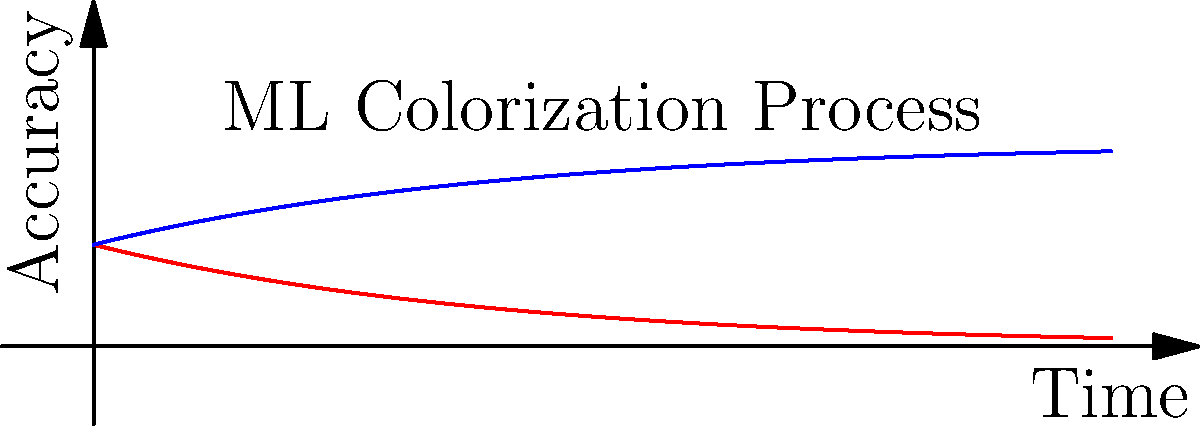In the context of using machine learning to colorize black and white film footage, what does the graph represent, and how might this information be used to improve the colorization process for classic films? The graph represents the accuracy of machine learning colorization over time. Let's break it down step-by-step:

1. The x-axis represents time, which could be interpreted as the progression of the colorization process or the evolution of the ML model.

2. The y-axis represents accuracy, indicating how close the colorized output is to the desired result.

3. The red curve (labeled "Original B&W") shows a decreasing function, which could represent the diminishing relevance or quality of the original black and white footage over time.

4. The blue curve (labeled "Colorized") shows an increasing function, representing the improving accuracy of the colorization process over time.

5. The intersection of these curves represents a point where the colorized version becomes more accurate or relevant than the original black and white footage.

For improving the colorization process of classic films:

1. Use this data to determine the optimal point to stop the colorization process, balancing accuracy with processing time.

2. Identify areas where the colorization accuracy plateaus, indicating where additional reference images or training data might be needed.

3. Compare the curves for different films or scenes to understand which types of footage are more challenging to colorize accurately.

4. Use the rate of accuracy improvement to estimate required computing resources and time for colorizing entire film libraries.

5. Develop strategies to push the blue curve higher more quickly, such as using more diverse reference images or advanced ML architectures.
Answer: Accuracy of ML colorization over time; guides process optimization and resource allocation 